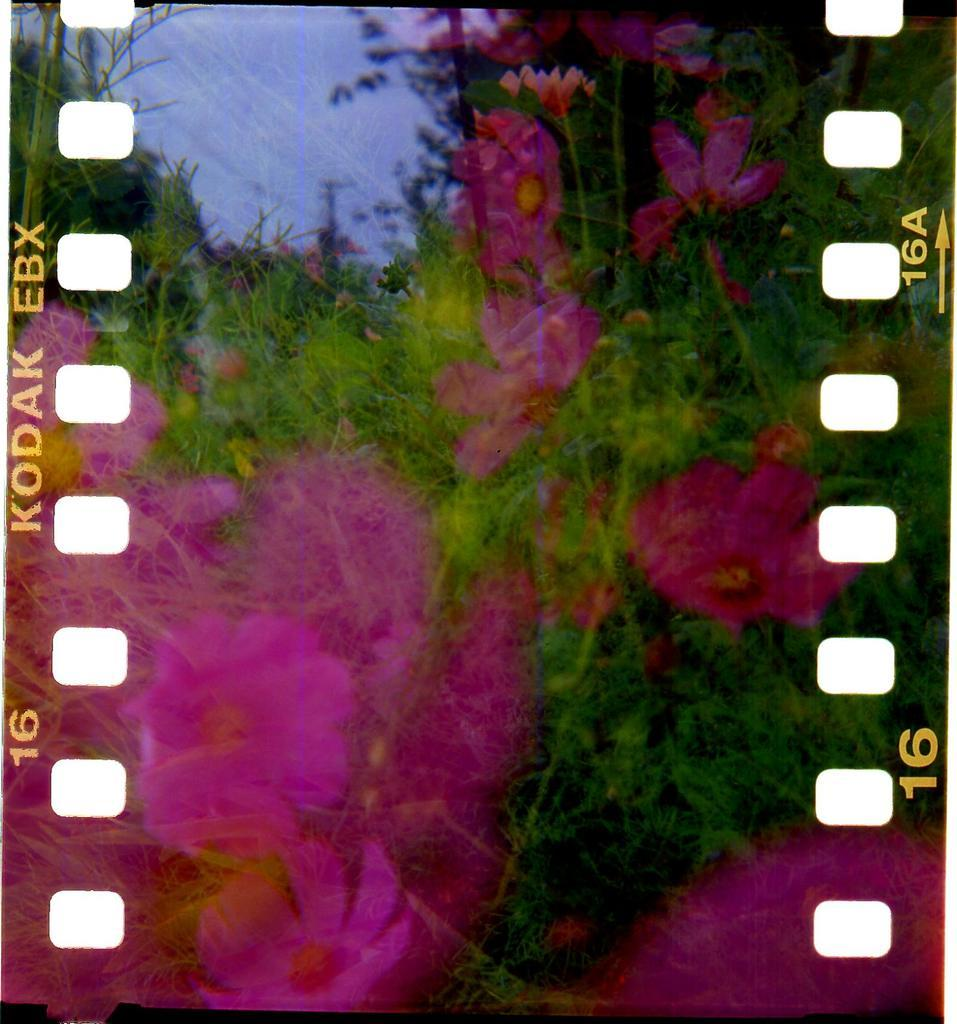What type of plants can be seen in the image? There are many flowers in the image. What color are the flowers in the image? The flowers are pink in color. What other objects are present in the image besides flowers? There is an electric pole in the image. What is the color of the sky in the image? The sky is pale blue in color. Is there any text present in the image? Yes, there is a text in the image. How many horses are visible in the image? There are no horses present in the image. What type of person can be seen interacting with the flowers in the image? There is no person present in the image; it only features flowers, plants, an electric pole, the sky, and text. 